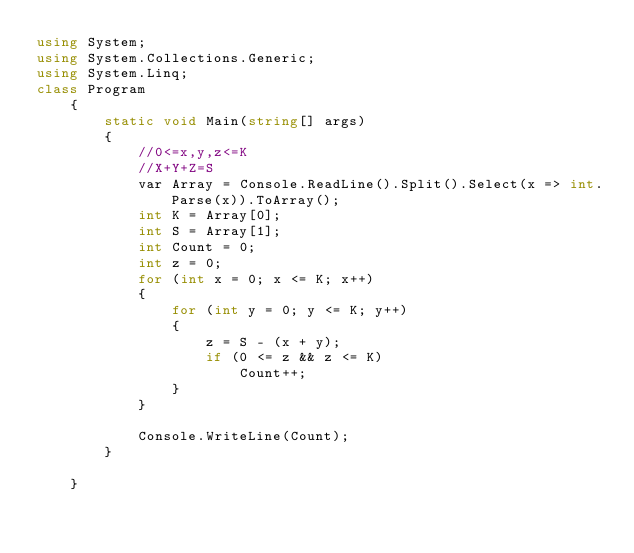<code> <loc_0><loc_0><loc_500><loc_500><_C#_>using System;
using System.Collections.Generic;
using System.Linq;
class Program
    {
        static void Main(string[] args)
        {
            //0<=x,y,z<=K
            //X+Y+Z=S
            var Array = Console.ReadLine().Split().Select(x => int.Parse(x)).ToArray();
            int K = Array[0];
            int S = Array[1];
            int Count = 0;
            int z = 0;
            for (int x = 0; x <= K; x++)
            {
                for (int y = 0; y <= K; y++)
                {
                    z = S - (x + y);
                    if (0 <= z && z <= K)
                        Count++;
                }
            }

            Console.WriteLine(Count);
        }

    }</code> 